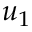Convert formula to latex. <formula><loc_0><loc_0><loc_500><loc_500>u _ { 1 }</formula> 